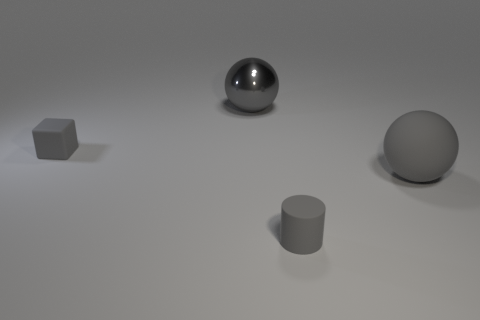Add 4 tiny gray matte cylinders. How many objects exist? 8 Subtract all blocks. How many objects are left? 3 Add 3 large spheres. How many large spheres exist? 5 Subtract 0 blue spheres. How many objects are left? 4 Subtract all purple cylinders. Subtract all red spheres. How many cylinders are left? 1 Subtract all big gray metal objects. Subtract all large gray metallic things. How many objects are left? 2 Add 2 large rubber spheres. How many large rubber spheres are left? 3 